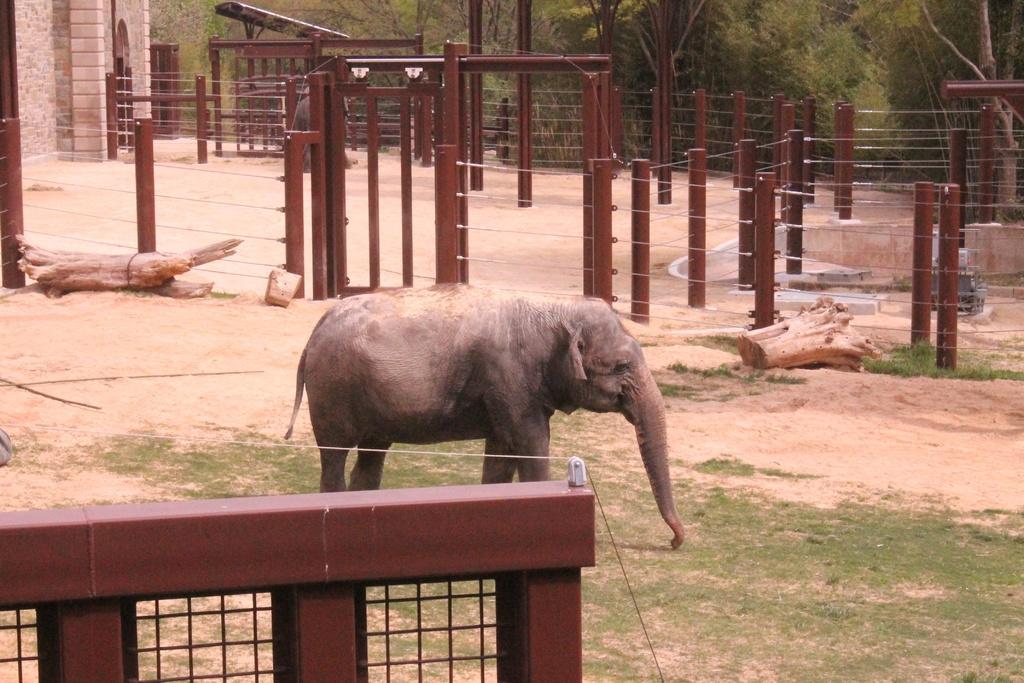In one or two sentences, can you explain what this image depicts? In this picture we can see an elephant is standing, at the bottom there is grass, in the middle we can see some wood and fencing, in the background there are some trees. 